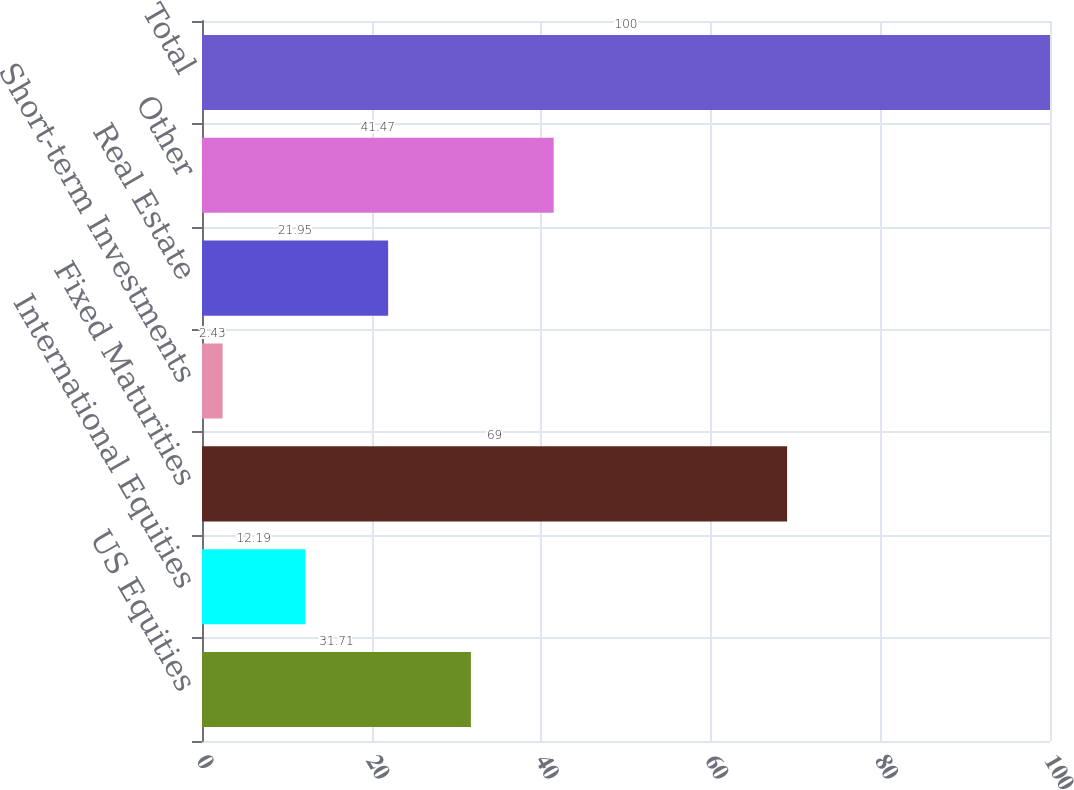Convert chart. <chart><loc_0><loc_0><loc_500><loc_500><bar_chart><fcel>US Equities<fcel>International Equities<fcel>Fixed Maturities<fcel>Short-term Investments<fcel>Real Estate<fcel>Other<fcel>Total<nl><fcel>31.71<fcel>12.19<fcel>69<fcel>2.43<fcel>21.95<fcel>41.47<fcel>100<nl></chart> 